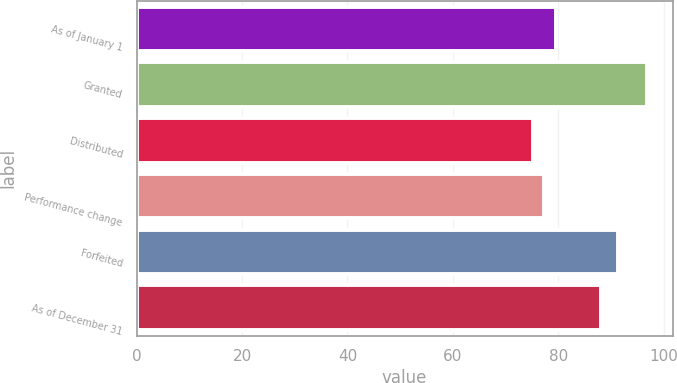Convert chart. <chart><loc_0><loc_0><loc_500><loc_500><bar_chart><fcel>As of January 1<fcel>Granted<fcel>Distributed<fcel>Performance change<fcel>Forfeited<fcel>As of December 31<nl><fcel>79.5<fcel>96.87<fcel>75.16<fcel>77.33<fcel>91.34<fcel>88.12<nl></chart> 